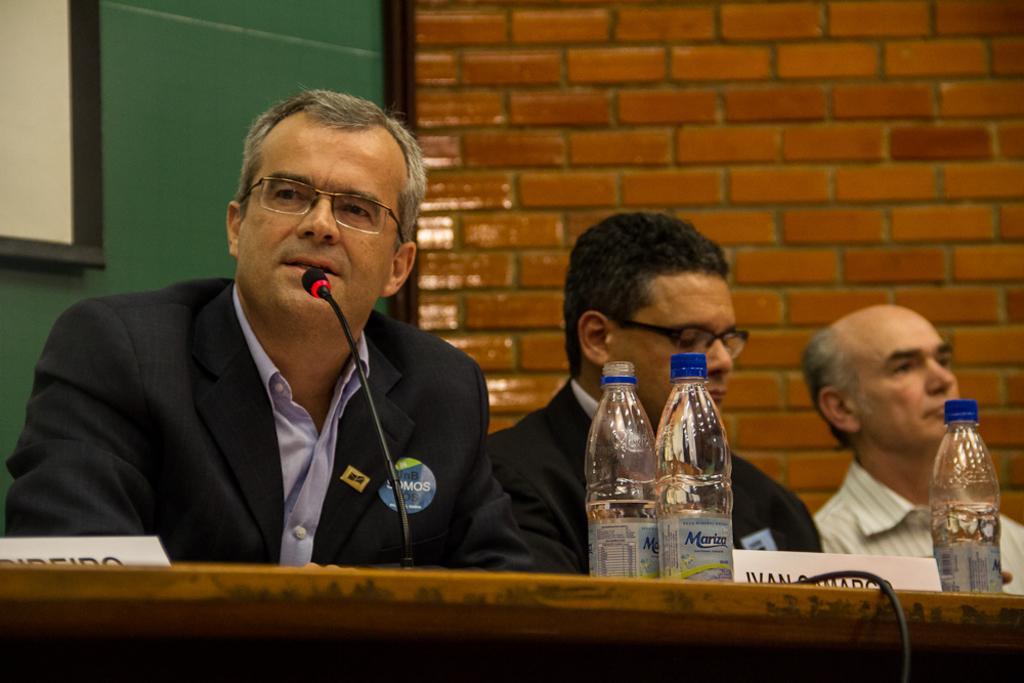How many people are sitting in the image? There are three persons sitting in the image. What is in front of the persons? There is a table in front of the persons. What object can be seen on the table? A microphone is present on the table. How many bottles are on the table? There are three bottles on the table. What can be seen in the background of the image? There is a notice board and a brick wall visible in the background. What color is the dress worn by the person sitting in the image? There is no person wearing a dress in the image; all three persons are wearing shirts. Can you tell me how high the tooth jumped in the image? There is no tooth or jumping action present in the image. 